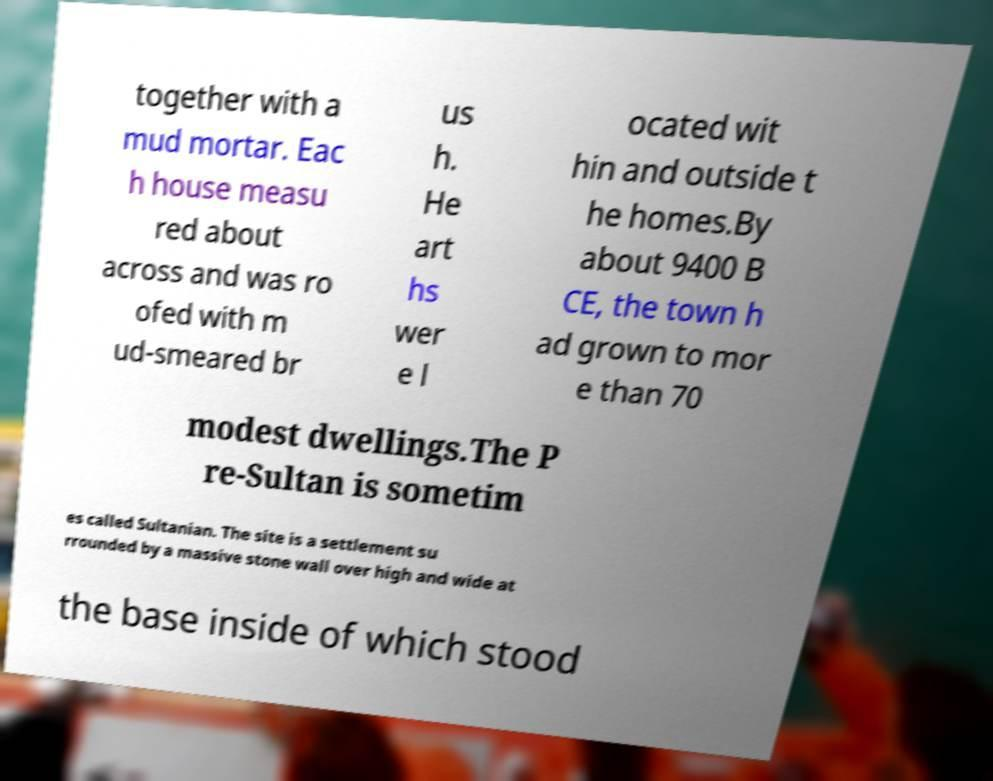What messages or text are displayed in this image? I need them in a readable, typed format. together with a mud mortar. Eac h house measu red about across and was ro ofed with m ud-smeared br us h. He art hs wer e l ocated wit hin and outside t he homes.By about 9400 B CE, the town h ad grown to mor e than 70 modest dwellings.The P re-Sultan is sometim es called Sultanian. The site is a settlement su rrounded by a massive stone wall over high and wide at the base inside of which stood 